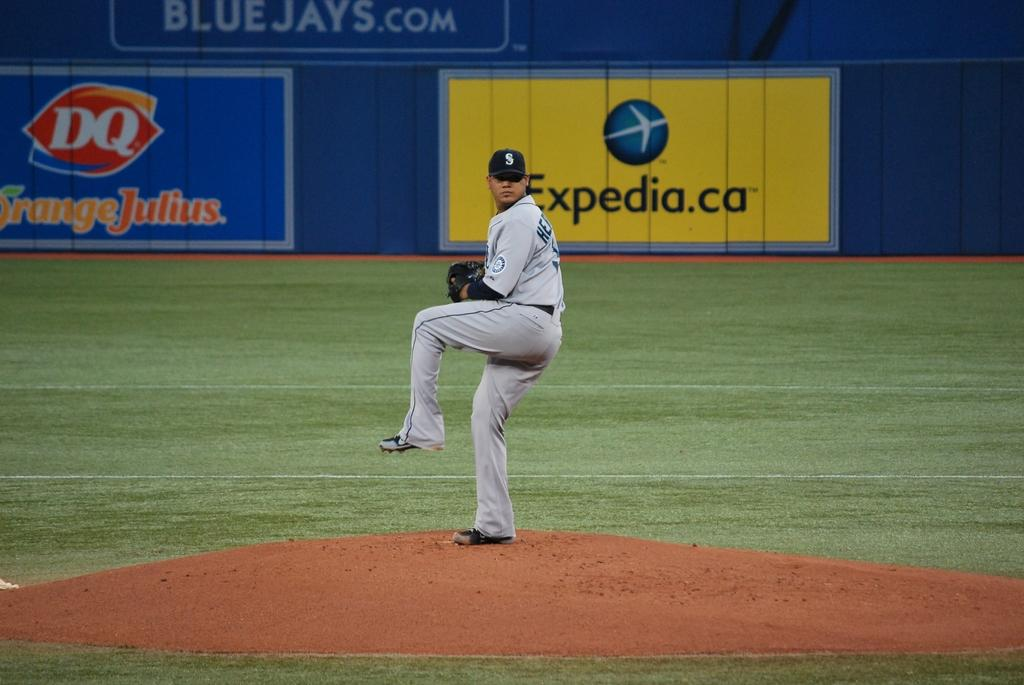Provide a one-sentence caption for the provided image. Pro baseball pitcher getting to throw a pitch from the mound with Expedia.ca and DQ sponsered sign boards in background. 